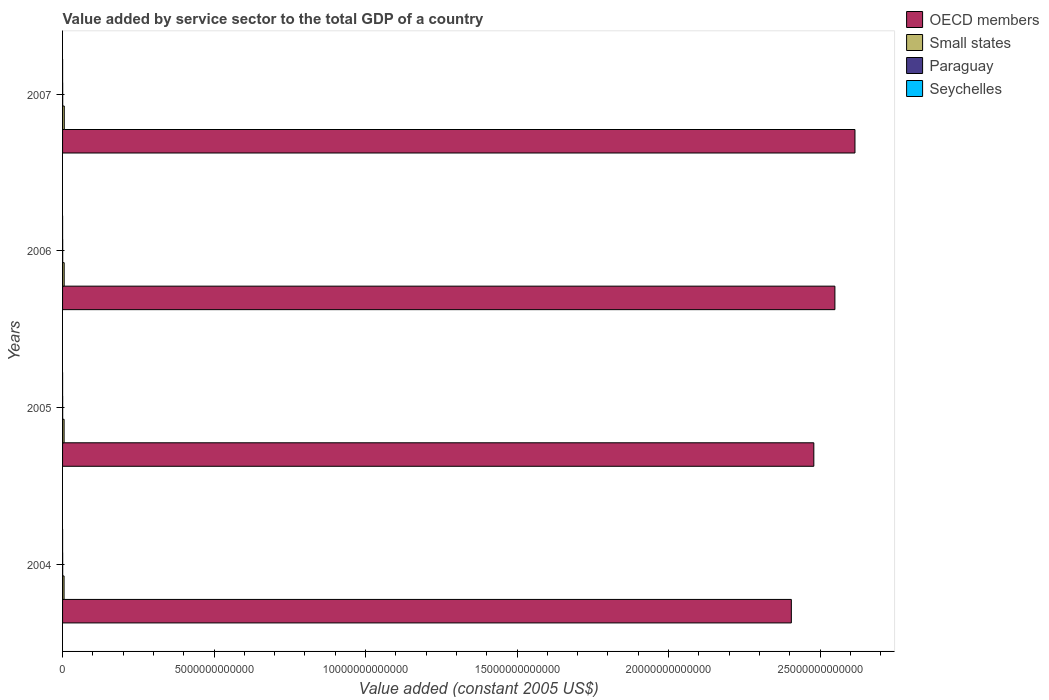How many groups of bars are there?
Give a very brief answer. 4. Are the number of bars per tick equal to the number of legend labels?
Offer a terse response. Yes. What is the label of the 1st group of bars from the top?
Offer a very short reply. 2007. In how many cases, is the number of bars for a given year not equal to the number of legend labels?
Your answer should be compact. 0. What is the value added by service sector in Small states in 2007?
Give a very brief answer. 5.63e+1. Across all years, what is the maximum value added by service sector in Small states?
Provide a succinct answer. 5.63e+1. Across all years, what is the minimum value added by service sector in OECD members?
Provide a succinct answer. 2.41e+13. In which year was the value added by service sector in Seychelles maximum?
Keep it short and to the point. 2007. In which year was the value added by service sector in Small states minimum?
Ensure brevity in your answer.  2004. What is the total value added by service sector in Seychelles in the graph?
Your answer should be very brief. 2.48e+09. What is the difference between the value added by service sector in Paraguay in 2004 and that in 2006?
Your answer should be compact. -3.68e+08. What is the difference between the value added by service sector in OECD members in 2004 and the value added by service sector in Small states in 2005?
Ensure brevity in your answer.  2.40e+13. What is the average value added by service sector in Small states per year?
Offer a terse response. 5.22e+1. In the year 2004, what is the difference between the value added by service sector in OECD members and value added by service sector in Seychelles?
Make the answer very short. 2.41e+13. In how many years, is the value added by service sector in Small states greater than 18000000000000 US$?
Ensure brevity in your answer.  0. What is the ratio of the value added by service sector in Small states in 2004 to that in 2007?
Ensure brevity in your answer.  0.87. What is the difference between the highest and the second highest value added by service sector in OECD members?
Offer a terse response. 6.62e+11. What is the difference between the highest and the lowest value added by service sector in Paraguay?
Your response must be concise. 5.76e+08. In how many years, is the value added by service sector in OECD members greater than the average value added by service sector in OECD members taken over all years?
Ensure brevity in your answer.  2. Is the sum of the value added by service sector in OECD members in 2005 and 2006 greater than the maximum value added by service sector in Small states across all years?
Offer a very short reply. Yes. Is it the case that in every year, the sum of the value added by service sector in OECD members and value added by service sector in Paraguay is greater than the sum of value added by service sector in Small states and value added by service sector in Seychelles?
Your answer should be very brief. Yes. What does the 3rd bar from the top in 2005 represents?
Your response must be concise. Small states. What does the 4th bar from the bottom in 2005 represents?
Make the answer very short. Seychelles. How many bars are there?
Give a very brief answer. 16. How many years are there in the graph?
Give a very brief answer. 4. What is the difference between two consecutive major ticks on the X-axis?
Make the answer very short. 5.00e+12. Does the graph contain any zero values?
Your response must be concise. No. Does the graph contain grids?
Give a very brief answer. No. Where does the legend appear in the graph?
Your response must be concise. Top right. How many legend labels are there?
Your response must be concise. 4. What is the title of the graph?
Keep it short and to the point. Value added by service sector to the total GDP of a country. What is the label or title of the X-axis?
Your answer should be compact. Value added (constant 2005 US$). What is the Value added (constant 2005 US$) in OECD members in 2004?
Offer a terse response. 2.41e+13. What is the Value added (constant 2005 US$) in Small states in 2004?
Offer a terse response. 4.92e+1. What is the Value added (constant 2005 US$) in Paraguay in 2004?
Offer a very short reply. 3.53e+09. What is the Value added (constant 2005 US$) of Seychelles in 2004?
Offer a very short reply. 5.39e+08. What is the Value added (constant 2005 US$) in OECD members in 2005?
Offer a terse response. 2.48e+13. What is the Value added (constant 2005 US$) in Small states in 2005?
Provide a succinct answer. 5.03e+1. What is the Value added (constant 2005 US$) of Paraguay in 2005?
Provide a succinct answer. 3.69e+09. What is the Value added (constant 2005 US$) of Seychelles in 2005?
Provide a succinct answer. 5.81e+08. What is the Value added (constant 2005 US$) of OECD members in 2006?
Offer a very short reply. 2.55e+13. What is the Value added (constant 2005 US$) of Small states in 2006?
Your response must be concise. 5.30e+1. What is the Value added (constant 2005 US$) of Paraguay in 2006?
Provide a succinct answer. 3.90e+09. What is the Value added (constant 2005 US$) of Seychelles in 2006?
Your answer should be very brief. 6.45e+08. What is the Value added (constant 2005 US$) in OECD members in 2007?
Your answer should be compact. 2.62e+13. What is the Value added (constant 2005 US$) in Small states in 2007?
Your answer should be compact. 5.63e+1. What is the Value added (constant 2005 US$) of Paraguay in 2007?
Your answer should be compact. 4.11e+09. What is the Value added (constant 2005 US$) in Seychelles in 2007?
Give a very brief answer. 7.18e+08. Across all years, what is the maximum Value added (constant 2005 US$) of OECD members?
Make the answer very short. 2.62e+13. Across all years, what is the maximum Value added (constant 2005 US$) in Small states?
Keep it short and to the point. 5.63e+1. Across all years, what is the maximum Value added (constant 2005 US$) in Paraguay?
Give a very brief answer. 4.11e+09. Across all years, what is the maximum Value added (constant 2005 US$) in Seychelles?
Your answer should be compact. 7.18e+08. Across all years, what is the minimum Value added (constant 2005 US$) in OECD members?
Your answer should be compact. 2.41e+13. Across all years, what is the minimum Value added (constant 2005 US$) of Small states?
Give a very brief answer. 4.92e+1. Across all years, what is the minimum Value added (constant 2005 US$) of Paraguay?
Make the answer very short. 3.53e+09. Across all years, what is the minimum Value added (constant 2005 US$) of Seychelles?
Give a very brief answer. 5.39e+08. What is the total Value added (constant 2005 US$) in OECD members in the graph?
Keep it short and to the point. 1.00e+14. What is the total Value added (constant 2005 US$) in Small states in the graph?
Ensure brevity in your answer.  2.09e+11. What is the total Value added (constant 2005 US$) in Paraguay in the graph?
Make the answer very short. 1.52e+1. What is the total Value added (constant 2005 US$) in Seychelles in the graph?
Provide a succinct answer. 2.48e+09. What is the difference between the Value added (constant 2005 US$) of OECD members in 2004 and that in 2005?
Provide a succinct answer. -7.42e+11. What is the difference between the Value added (constant 2005 US$) of Small states in 2004 and that in 2005?
Your response must be concise. -1.11e+09. What is the difference between the Value added (constant 2005 US$) of Paraguay in 2004 and that in 2005?
Keep it short and to the point. -1.53e+08. What is the difference between the Value added (constant 2005 US$) in Seychelles in 2004 and that in 2005?
Make the answer very short. -4.19e+07. What is the difference between the Value added (constant 2005 US$) in OECD members in 2004 and that in 2006?
Your answer should be very brief. -1.44e+12. What is the difference between the Value added (constant 2005 US$) of Small states in 2004 and that in 2006?
Your answer should be compact. -3.77e+09. What is the difference between the Value added (constant 2005 US$) of Paraguay in 2004 and that in 2006?
Provide a short and direct response. -3.68e+08. What is the difference between the Value added (constant 2005 US$) in Seychelles in 2004 and that in 2006?
Offer a very short reply. -1.06e+08. What is the difference between the Value added (constant 2005 US$) of OECD members in 2004 and that in 2007?
Ensure brevity in your answer.  -2.10e+12. What is the difference between the Value added (constant 2005 US$) in Small states in 2004 and that in 2007?
Keep it short and to the point. -7.07e+09. What is the difference between the Value added (constant 2005 US$) in Paraguay in 2004 and that in 2007?
Keep it short and to the point. -5.76e+08. What is the difference between the Value added (constant 2005 US$) of Seychelles in 2004 and that in 2007?
Your response must be concise. -1.79e+08. What is the difference between the Value added (constant 2005 US$) of OECD members in 2005 and that in 2006?
Provide a succinct answer. -6.96e+11. What is the difference between the Value added (constant 2005 US$) of Small states in 2005 and that in 2006?
Keep it short and to the point. -2.66e+09. What is the difference between the Value added (constant 2005 US$) of Paraguay in 2005 and that in 2006?
Your answer should be very brief. -2.15e+08. What is the difference between the Value added (constant 2005 US$) of Seychelles in 2005 and that in 2006?
Offer a terse response. -6.36e+07. What is the difference between the Value added (constant 2005 US$) in OECD members in 2005 and that in 2007?
Provide a short and direct response. -1.36e+12. What is the difference between the Value added (constant 2005 US$) of Small states in 2005 and that in 2007?
Your answer should be compact. -5.96e+09. What is the difference between the Value added (constant 2005 US$) of Paraguay in 2005 and that in 2007?
Provide a succinct answer. -4.22e+08. What is the difference between the Value added (constant 2005 US$) of Seychelles in 2005 and that in 2007?
Provide a succinct answer. -1.37e+08. What is the difference between the Value added (constant 2005 US$) of OECD members in 2006 and that in 2007?
Your answer should be very brief. -6.62e+11. What is the difference between the Value added (constant 2005 US$) of Small states in 2006 and that in 2007?
Provide a succinct answer. -3.30e+09. What is the difference between the Value added (constant 2005 US$) in Paraguay in 2006 and that in 2007?
Keep it short and to the point. -2.07e+08. What is the difference between the Value added (constant 2005 US$) of Seychelles in 2006 and that in 2007?
Make the answer very short. -7.31e+07. What is the difference between the Value added (constant 2005 US$) in OECD members in 2004 and the Value added (constant 2005 US$) in Small states in 2005?
Your answer should be compact. 2.40e+13. What is the difference between the Value added (constant 2005 US$) in OECD members in 2004 and the Value added (constant 2005 US$) in Paraguay in 2005?
Provide a short and direct response. 2.40e+13. What is the difference between the Value added (constant 2005 US$) in OECD members in 2004 and the Value added (constant 2005 US$) in Seychelles in 2005?
Offer a very short reply. 2.41e+13. What is the difference between the Value added (constant 2005 US$) of Small states in 2004 and the Value added (constant 2005 US$) of Paraguay in 2005?
Offer a very short reply. 4.55e+1. What is the difference between the Value added (constant 2005 US$) in Small states in 2004 and the Value added (constant 2005 US$) in Seychelles in 2005?
Provide a succinct answer. 4.87e+1. What is the difference between the Value added (constant 2005 US$) in Paraguay in 2004 and the Value added (constant 2005 US$) in Seychelles in 2005?
Your answer should be compact. 2.95e+09. What is the difference between the Value added (constant 2005 US$) of OECD members in 2004 and the Value added (constant 2005 US$) of Small states in 2006?
Provide a succinct answer. 2.40e+13. What is the difference between the Value added (constant 2005 US$) of OECD members in 2004 and the Value added (constant 2005 US$) of Paraguay in 2006?
Make the answer very short. 2.40e+13. What is the difference between the Value added (constant 2005 US$) in OECD members in 2004 and the Value added (constant 2005 US$) in Seychelles in 2006?
Provide a succinct answer. 2.41e+13. What is the difference between the Value added (constant 2005 US$) of Small states in 2004 and the Value added (constant 2005 US$) of Paraguay in 2006?
Keep it short and to the point. 4.53e+1. What is the difference between the Value added (constant 2005 US$) in Small states in 2004 and the Value added (constant 2005 US$) in Seychelles in 2006?
Ensure brevity in your answer.  4.86e+1. What is the difference between the Value added (constant 2005 US$) of Paraguay in 2004 and the Value added (constant 2005 US$) of Seychelles in 2006?
Offer a very short reply. 2.89e+09. What is the difference between the Value added (constant 2005 US$) in OECD members in 2004 and the Value added (constant 2005 US$) in Small states in 2007?
Keep it short and to the point. 2.40e+13. What is the difference between the Value added (constant 2005 US$) in OECD members in 2004 and the Value added (constant 2005 US$) in Paraguay in 2007?
Ensure brevity in your answer.  2.40e+13. What is the difference between the Value added (constant 2005 US$) in OECD members in 2004 and the Value added (constant 2005 US$) in Seychelles in 2007?
Give a very brief answer. 2.41e+13. What is the difference between the Value added (constant 2005 US$) of Small states in 2004 and the Value added (constant 2005 US$) of Paraguay in 2007?
Your response must be concise. 4.51e+1. What is the difference between the Value added (constant 2005 US$) of Small states in 2004 and the Value added (constant 2005 US$) of Seychelles in 2007?
Provide a succinct answer. 4.85e+1. What is the difference between the Value added (constant 2005 US$) in Paraguay in 2004 and the Value added (constant 2005 US$) in Seychelles in 2007?
Offer a very short reply. 2.82e+09. What is the difference between the Value added (constant 2005 US$) of OECD members in 2005 and the Value added (constant 2005 US$) of Small states in 2006?
Your answer should be very brief. 2.47e+13. What is the difference between the Value added (constant 2005 US$) of OECD members in 2005 and the Value added (constant 2005 US$) of Paraguay in 2006?
Your answer should be compact. 2.48e+13. What is the difference between the Value added (constant 2005 US$) in OECD members in 2005 and the Value added (constant 2005 US$) in Seychelles in 2006?
Make the answer very short. 2.48e+13. What is the difference between the Value added (constant 2005 US$) in Small states in 2005 and the Value added (constant 2005 US$) in Paraguay in 2006?
Make the answer very short. 4.64e+1. What is the difference between the Value added (constant 2005 US$) in Small states in 2005 and the Value added (constant 2005 US$) in Seychelles in 2006?
Keep it short and to the point. 4.97e+1. What is the difference between the Value added (constant 2005 US$) in Paraguay in 2005 and the Value added (constant 2005 US$) in Seychelles in 2006?
Your answer should be very brief. 3.04e+09. What is the difference between the Value added (constant 2005 US$) in OECD members in 2005 and the Value added (constant 2005 US$) in Small states in 2007?
Provide a short and direct response. 2.47e+13. What is the difference between the Value added (constant 2005 US$) in OECD members in 2005 and the Value added (constant 2005 US$) in Paraguay in 2007?
Your response must be concise. 2.48e+13. What is the difference between the Value added (constant 2005 US$) in OECD members in 2005 and the Value added (constant 2005 US$) in Seychelles in 2007?
Provide a short and direct response. 2.48e+13. What is the difference between the Value added (constant 2005 US$) in Small states in 2005 and the Value added (constant 2005 US$) in Paraguay in 2007?
Offer a terse response. 4.62e+1. What is the difference between the Value added (constant 2005 US$) in Small states in 2005 and the Value added (constant 2005 US$) in Seychelles in 2007?
Offer a very short reply. 4.96e+1. What is the difference between the Value added (constant 2005 US$) in Paraguay in 2005 and the Value added (constant 2005 US$) in Seychelles in 2007?
Your response must be concise. 2.97e+09. What is the difference between the Value added (constant 2005 US$) in OECD members in 2006 and the Value added (constant 2005 US$) in Small states in 2007?
Your response must be concise. 2.54e+13. What is the difference between the Value added (constant 2005 US$) in OECD members in 2006 and the Value added (constant 2005 US$) in Paraguay in 2007?
Your answer should be compact. 2.55e+13. What is the difference between the Value added (constant 2005 US$) in OECD members in 2006 and the Value added (constant 2005 US$) in Seychelles in 2007?
Your answer should be very brief. 2.55e+13. What is the difference between the Value added (constant 2005 US$) of Small states in 2006 and the Value added (constant 2005 US$) of Paraguay in 2007?
Your response must be concise. 4.89e+1. What is the difference between the Value added (constant 2005 US$) in Small states in 2006 and the Value added (constant 2005 US$) in Seychelles in 2007?
Offer a terse response. 5.23e+1. What is the difference between the Value added (constant 2005 US$) of Paraguay in 2006 and the Value added (constant 2005 US$) of Seychelles in 2007?
Your answer should be compact. 3.19e+09. What is the average Value added (constant 2005 US$) of OECD members per year?
Your answer should be very brief. 2.51e+13. What is the average Value added (constant 2005 US$) of Small states per year?
Your answer should be compact. 5.22e+1. What is the average Value added (constant 2005 US$) of Paraguay per year?
Provide a succinct answer. 3.81e+09. What is the average Value added (constant 2005 US$) in Seychelles per year?
Give a very brief answer. 6.21e+08. In the year 2004, what is the difference between the Value added (constant 2005 US$) in OECD members and Value added (constant 2005 US$) in Small states?
Ensure brevity in your answer.  2.40e+13. In the year 2004, what is the difference between the Value added (constant 2005 US$) in OECD members and Value added (constant 2005 US$) in Paraguay?
Give a very brief answer. 2.40e+13. In the year 2004, what is the difference between the Value added (constant 2005 US$) of OECD members and Value added (constant 2005 US$) of Seychelles?
Provide a succinct answer. 2.41e+13. In the year 2004, what is the difference between the Value added (constant 2005 US$) in Small states and Value added (constant 2005 US$) in Paraguay?
Your response must be concise. 4.57e+1. In the year 2004, what is the difference between the Value added (constant 2005 US$) of Small states and Value added (constant 2005 US$) of Seychelles?
Your response must be concise. 4.87e+1. In the year 2004, what is the difference between the Value added (constant 2005 US$) in Paraguay and Value added (constant 2005 US$) in Seychelles?
Offer a very short reply. 3.00e+09. In the year 2005, what is the difference between the Value added (constant 2005 US$) in OECD members and Value added (constant 2005 US$) in Small states?
Ensure brevity in your answer.  2.47e+13. In the year 2005, what is the difference between the Value added (constant 2005 US$) in OECD members and Value added (constant 2005 US$) in Paraguay?
Offer a very short reply. 2.48e+13. In the year 2005, what is the difference between the Value added (constant 2005 US$) in OECD members and Value added (constant 2005 US$) in Seychelles?
Make the answer very short. 2.48e+13. In the year 2005, what is the difference between the Value added (constant 2005 US$) in Small states and Value added (constant 2005 US$) in Paraguay?
Ensure brevity in your answer.  4.67e+1. In the year 2005, what is the difference between the Value added (constant 2005 US$) of Small states and Value added (constant 2005 US$) of Seychelles?
Keep it short and to the point. 4.98e+1. In the year 2005, what is the difference between the Value added (constant 2005 US$) in Paraguay and Value added (constant 2005 US$) in Seychelles?
Give a very brief answer. 3.11e+09. In the year 2006, what is the difference between the Value added (constant 2005 US$) in OECD members and Value added (constant 2005 US$) in Small states?
Your answer should be very brief. 2.54e+13. In the year 2006, what is the difference between the Value added (constant 2005 US$) of OECD members and Value added (constant 2005 US$) of Paraguay?
Ensure brevity in your answer.  2.55e+13. In the year 2006, what is the difference between the Value added (constant 2005 US$) of OECD members and Value added (constant 2005 US$) of Seychelles?
Give a very brief answer. 2.55e+13. In the year 2006, what is the difference between the Value added (constant 2005 US$) of Small states and Value added (constant 2005 US$) of Paraguay?
Your answer should be very brief. 4.91e+1. In the year 2006, what is the difference between the Value added (constant 2005 US$) of Small states and Value added (constant 2005 US$) of Seychelles?
Your answer should be compact. 5.24e+1. In the year 2006, what is the difference between the Value added (constant 2005 US$) in Paraguay and Value added (constant 2005 US$) in Seychelles?
Give a very brief answer. 3.26e+09. In the year 2007, what is the difference between the Value added (constant 2005 US$) in OECD members and Value added (constant 2005 US$) in Small states?
Give a very brief answer. 2.61e+13. In the year 2007, what is the difference between the Value added (constant 2005 US$) of OECD members and Value added (constant 2005 US$) of Paraguay?
Provide a succinct answer. 2.61e+13. In the year 2007, what is the difference between the Value added (constant 2005 US$) in OECD members and Value added (constant 2005 US$) in Seychelles?
Give a very brief answer. 2.62e+13. In the year 2007, what is the difference between the Value added (constant 2005 US$) of Small states and Value added (constant 2005 US$) of Paraguay?
Give a very brief answer. 5.22e+1. In the year 2007, what is the difference between the Value added (constant 2005 US$) of Small states and Value added (constant 2005 US$) of Seychelles?
Offer a very short reply. 5.56e+1. In the year 2007, what is the difference between the Value added (constant 2005 US$) of Paraguay and Value added (constant 2005 US$) of Seychelles?
Ensure brevity in your answer.  3.39e+09. What is the ratio of the Value added (constant 2005 US$) of OECD members in 2004 to that in 2005?
Keep it short and to the point. 0.97. What is the ratio of the Value added (constant 2005 US$) of Small states in 2004 to that in 2005?
Your answer should be very brief. 0.98. What is the ratio of the Value added (constant 2005 US$) in Paraguay in 2004 to that in 2005?
Provide a succinct answer. 0.96. What is the ratio of the Value added (constant 2005 US$) in Seychelles in 2004 to that in 2005?
Keep it short and to the point. 0.93. What is the ratio of the Value added (constant 2005 US$) of OECD members in 2004 to that in 2006?
Your answer should be very brief. 0.94. What is the ratio of the Value added (constant 2005 US$) in Small states in 2004 to that in 2006?
Offer a very short reply. 0.93. What is the ratio of the Value added (constant 2005 US$) in Paraguay in 2004 to that in 2006?
Make the answer very short. 0.91. What is the ratio of the Value added (constant 2005 US$) of Seychelles in 2004 to that in 2006?
Ensure brevity in your answer.  0.84. What is the ratio of the Value added (constant 2005 US$) of OECD members in 2004 to that in 2007?
Your answer should be compact. 0.92. What is the ratio of the Value added (constant 2005 US$) of Small states in 2004 to that in 2007?
Make the answer very short. 0.87. What is the ratio of the Value added (constant 2005 US$) in Paraguay in 2004 to that in 2007?
Ensure brevity in your answer.  0.86. What is the ratio of the Value added (constant 2005 US$) in Seychelles in 2004 to that in 2007?
Ensure brevity in your answer.  0.75. What is the ratio of the Value added (constant 2005 US$) of OECD members in 2005 to that in 2006?
Offer a very short reply. 0.97. What is the ratio of the Value added (constant 2005 US$) of Small states in 2005 to that in 2006?
Offer a terse response. 0.95. What is the ratio of the Value added (constant 2005 US$) in Paraguay in 2005 to that in 2006?
Ensure brevity in your answer.  0.94. What is the ratio of the Value added (constant 2005 US$) in Seychelles in 2005 to that in 2006?
Make the answer very short. 0.9. What is the ratio of the Value added (constant 2005 US$) of OECD members in 2005 to that in 2007?
Offer a terse response. 0.95. What is the ratio of the Value added (constant 2005 US$) in Small states in 2005 to that in 2007?
Offer a terse response. 0.89. What is the ratio of the Value added (constant 2005 US$) in Paraguay in 2005 to that in 2007?
Your answer should be very brief. 0.9. What is the ratio of the Value added (constant 2005 US$) in Seychelles in 2005 to that in 2007?
Your response must be concise. 0.81. What is the ratio of the Value added (constant 2005 US$) of OECD members in 2006 to that in 2007?
Your answer should be compact. 0.97. What is the ratio of the Value added (constant 2005 US$) of Small states in 2006 to that in 2007?
Your answer should be very brief. 0.94. What is the ratio of the Value added (constant 2005 US$) of Paraguay in 2006 to that in 2007?
Make the answer very short. 0.95. What is the ratio of the Value added (constant 2005 US$) of Seychelles in 2006 to that in 2007?
Provide a short and direct response. 0.9. What is the difference between the highest and the second highest Value added (constant 2005 US$) of OECD members?
Ensure brevity in your answer.  6.62e+11. What is the difference between the highest and the second highest Value added (constant 2005 US$) in Small states?
Your answer should be compact. 3.30e+09. What is the difference between the highest and the second highest Value added (constant 2005 US$) of Paraguay?
Your answer should be very brief. 2.07e+08. What is the difference between the highest and the second highest Value added (constant 2005 US$) of Seychelles?
Make the answer very short. 7.31e+07. What is the difference between the highest and the lowest Value added (constant 2005 US$) of OECD members?
Your answer should be very brief. 2.10e+12. What is the difference between the highest and the lowest Value added (constant 2005 US$) of Small states?
Offer a terse response. 7.07e+09. What is the difference between the highest and the lowest Value added (constant 2005 US$) of Paraguay?
Make the answer very short. 5.76e+08. What is the difference between the highest and the lowest Value added (constant 2005 US$) in Seychelles?
Offer a terse response. 1.79e+08. 